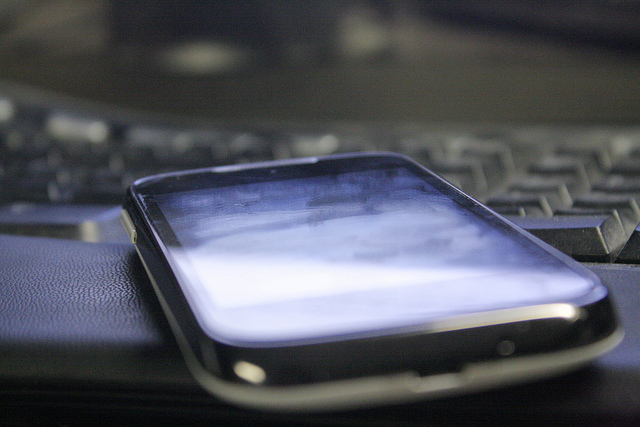<image>What style cell phone is shown? I don't know the exact style of the cell phone, but it is a smartphone. It could be a Samsung, iPhone or Android device. What style cell phone is shown? I don't know what style cell phone is shown. It can be a smartphone, Samsung, iPhone or Android phone. 